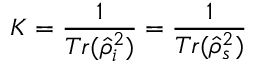<formula> <loc_0><loc_0><loc_500><loc_500>K = \frac { 1 } { T r ( \hat { \rho } _ { i } ^ { 2 } ) } = \frac { 1 } { T r ( \hat { \rho } _ { s } ^ { 2 } ) }</formula> 